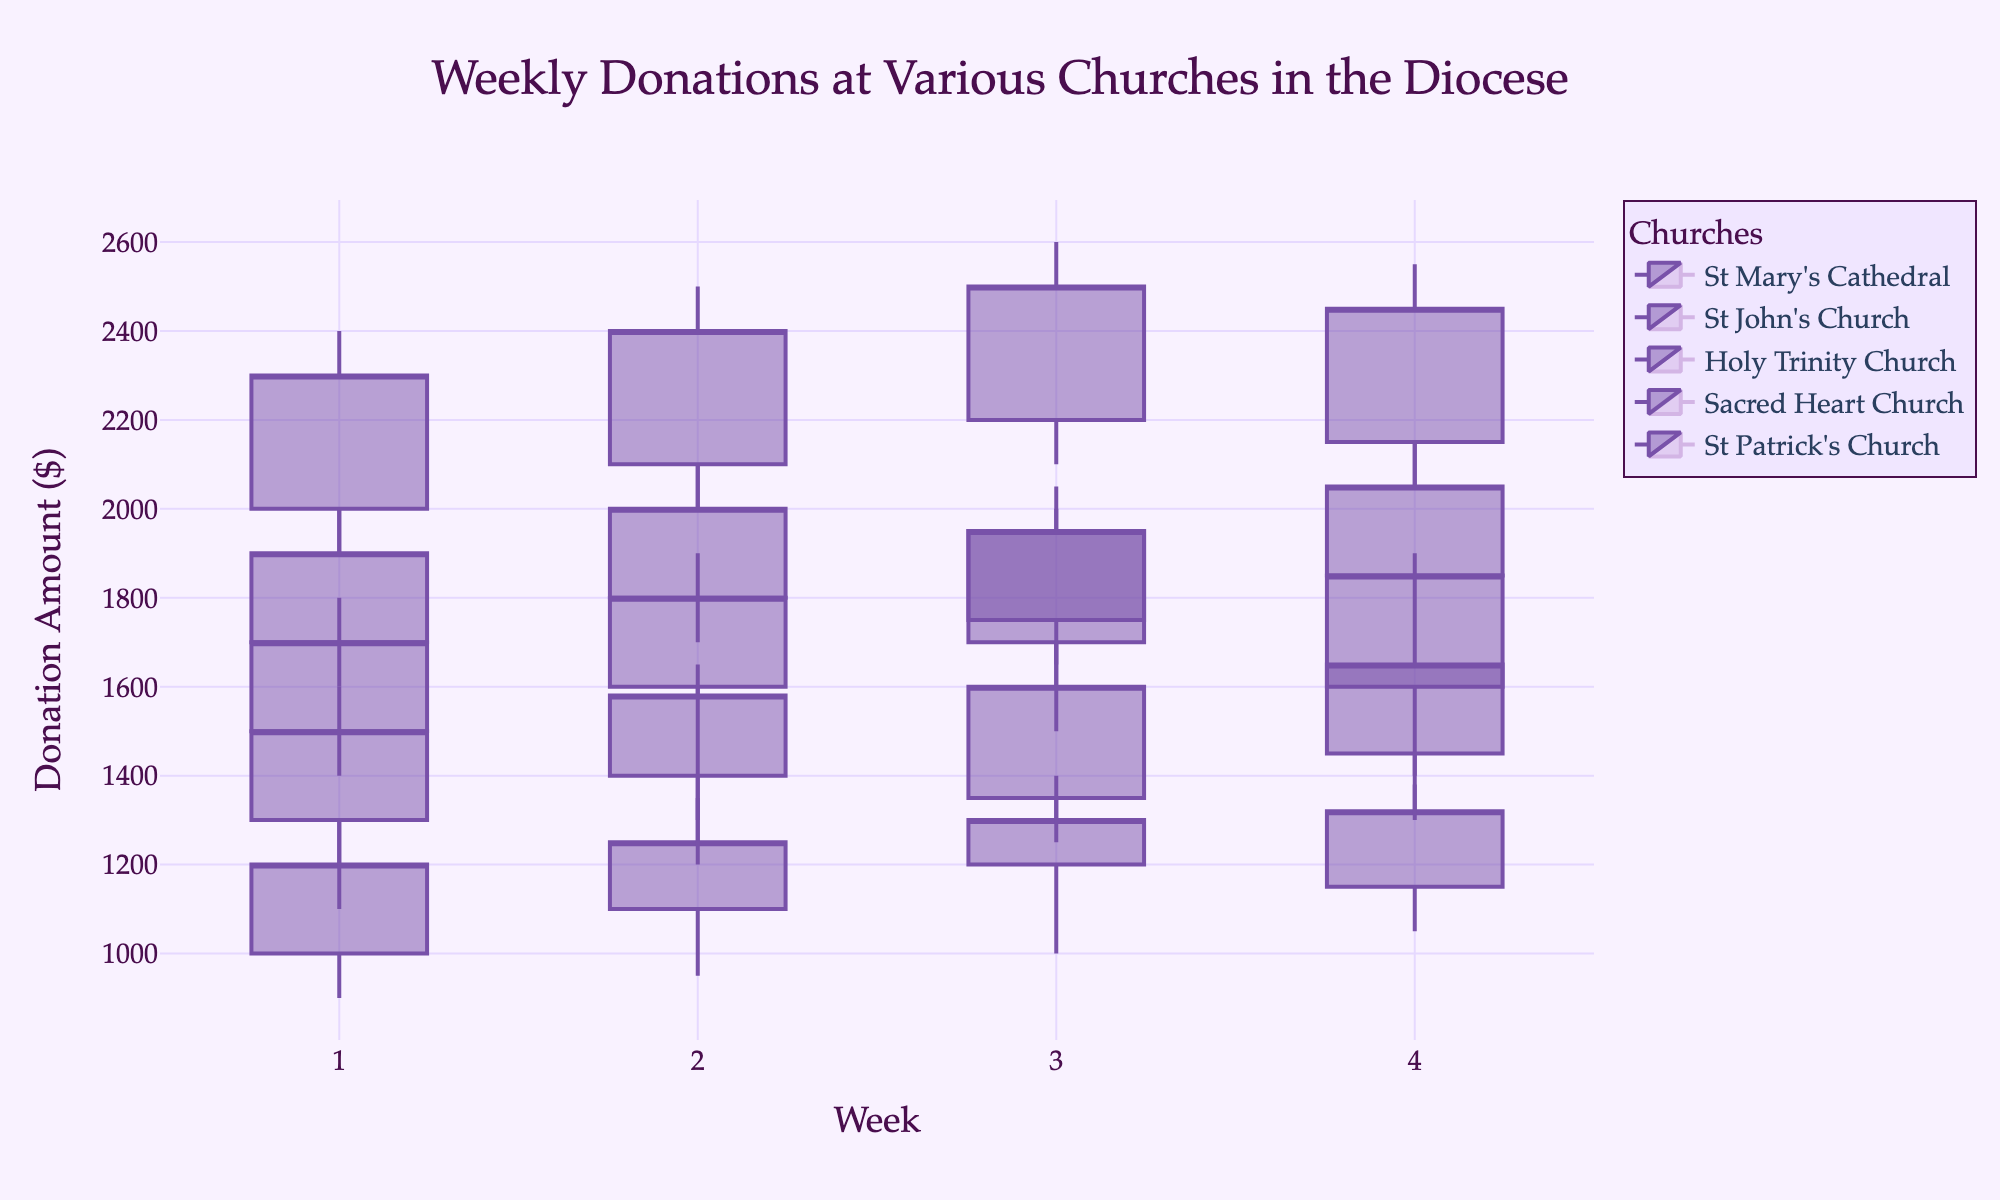What is the title of the figure? The title is the text that describes what the plot represents. It is usually located at the top of the figure.
Answer: Weekly Donations at Various Churches in the Diocese Which church showed the highest closing donation in the first week? Look at the data points labeled Week 1 for each church and find the one with the highest 'close' value.
Answer: Sacred Heart Church What is the range of donation amounts for St. Patrick's Church in Week 2? The range is calculated by subtracting the lowest donation amount from the highest donation amount for Week 2 of St. Patrick's Church. The range is 2100 (high) - 1700 (low) = 400.
Answer: 400 Which church had the most consistent donation amounts over the four weeks? Consistency in a candlestick plot can be evaluated by finding the church with the smallest difference between highs and lows over the four weeks.
Answer: St. John's Church How did donations at St. Mary's Cathedral change from Week 2 to Week 3? Compare Week 2 and Week 3 'close' values for St. Mary's Cathedral. Subtract the Week 2 close value from the Week 3 close value. 1950 (Week 3) - 1800 (Week 2) = 150
Answer: Increased by 150 Which week had the highest total donations across all churches? Add the 'close' values for all churches for each week and compare to find the highest total.
Answer: Week 3 Were any weeks at St. John's Church marked by decreasing donations? Look for weeks where the 'close' value is less than the 'open' value. For St. John's Church, compare Week 3 and Week 4.
Answer: No What is the closing trend for Holy Trinity Church over the four weeks? Analyze the 'close' values for all four weeks to identify the trend. The 'close' values are increasing each week.
Answer: Increasing Which church had the highest peak donation amount in Week 3? Look at the 'high' values for Week 3 across all churches and find the maximum.
Answer: Sacred Heart Church 